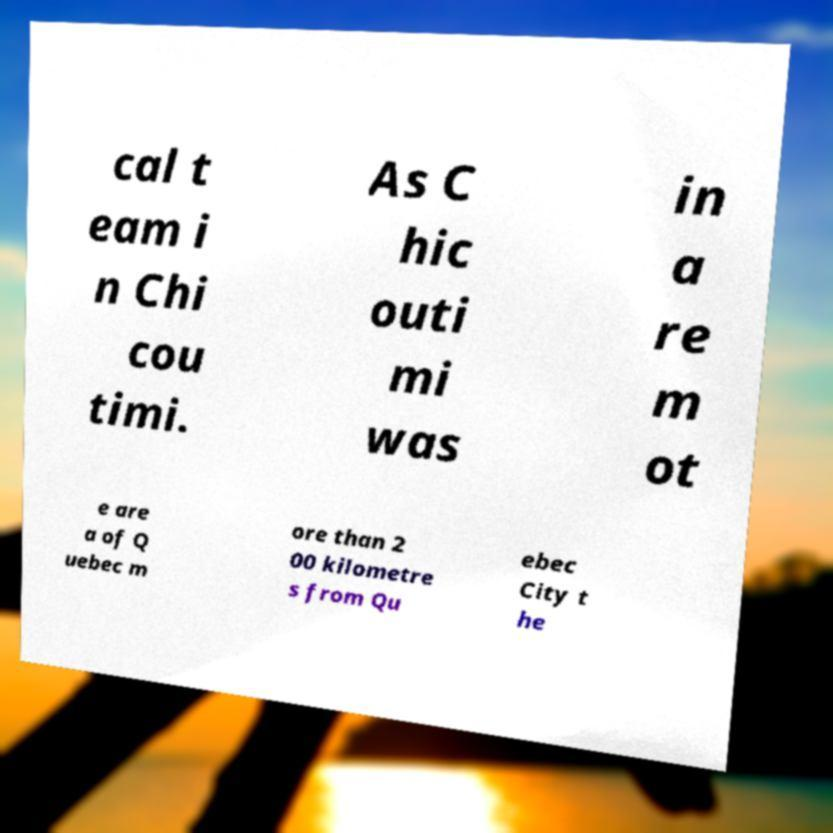Can you read and provide the text displayed in the image?This photo seems to have some interesting text. Can you extract and type it out for me? cal t eam i n Chi cou timi. As C hic outi mi was in a re m ot e are a of Q uebec m ore than 2 00 kilometre s from Qu ebec City t he 